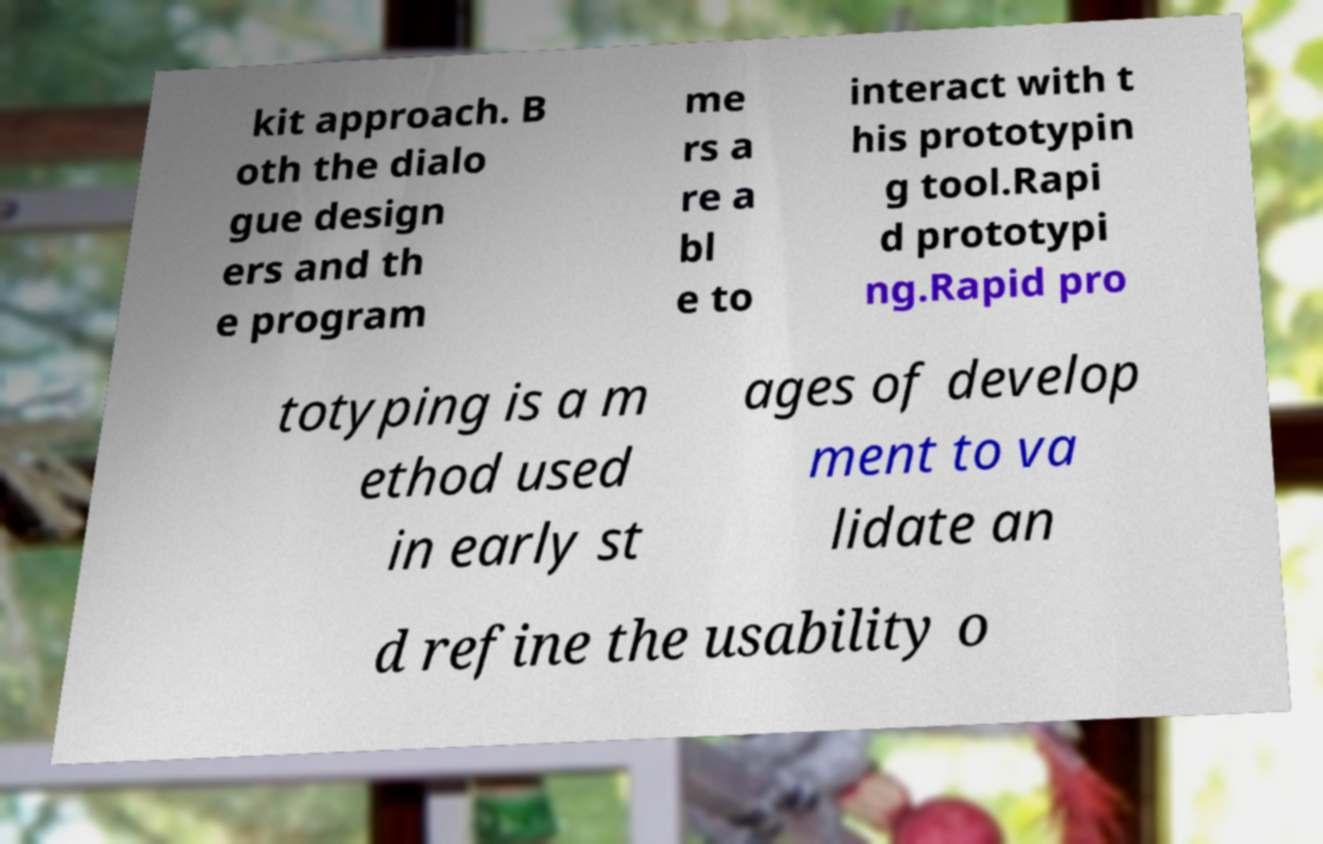Please read and relay the text visible in this image. What does it say? kit approach. B oth the dialo gue design ers and th e program me rs a re a bl e to interact with t his prototypin g tool.Rapi d prototypi ng.Rapid pro totyping is a m ethod used in early st ages of develop ment to va lidate an d refine the usability o 